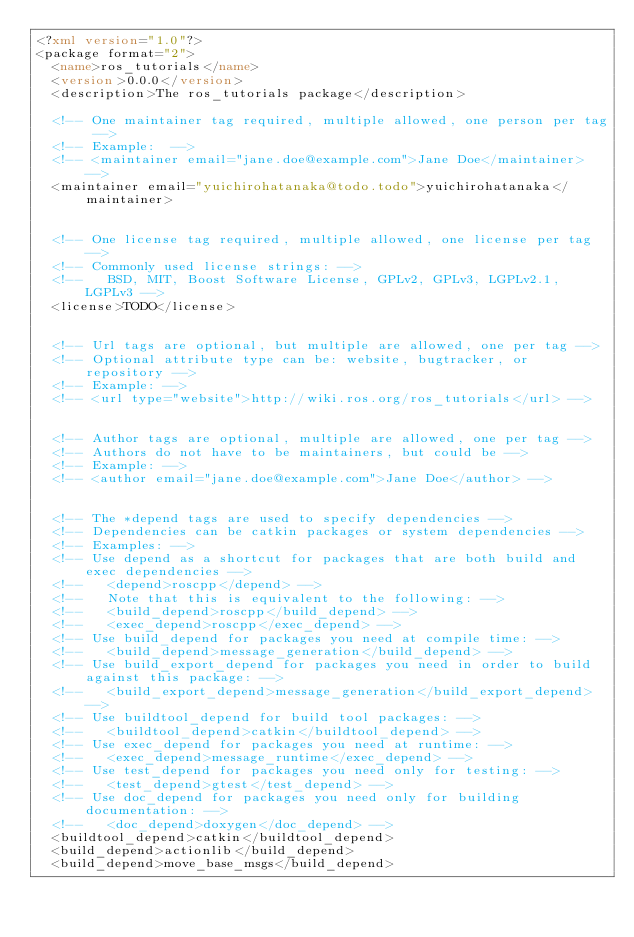Convert code to text. <code><loc_0><loc_0><loc_500><loc_500><_XML_><?xml version="1.0"?>
<package format="2">
  <name>ros_tutorials</name>
  <version>0.0.0</version>
  <description>The ros_tutorials package</description>

  <!-- One maintainer tag required, multiple allowed, one person per tag -->
  <!-- Example:  -->
  <!-- <maintainer email="jane.doe@example.com">Jane Doe</maintainer> -->
  <maintainer email="yuichirohatanaka@todo.todo">yuichirohatanaka</maintainer>


  <!-- One license tag required, multiple allowed, one license per tag -->
  <!-- Commonly used license strings: -->
  <!--   BSD, MIT, Boost Software License, GPLv2, GPLv3, LGPLv2.1, LGPLv3 -->
  <license>TODO</license>


  <!-- Url tags are optional, but multiple are allowed, one per tag -->
  <!-- Optional attribute type can be: website, bugtracker, or repository -->
  <!-- Example: -->
  <!-- <url type="website">http://wiki.ros.org/ros_tutorials</url> -->


  <!-- Author tags are optional, multiple are allowed, one per tag -->
  <!-- Authors do not have to be maintainers, but could be -->
  <!-- Example: -->
  <!-- <author email="jane.doe@example.com">Jane Doe</author> -->


  <!-- The *depend tags are used to specify dependencies -->
  <!-- Dependencies can be catkin packages or system dependencies -->
  <!-- Examples: -->
  <!-- Use depend as a shortcut for packages that are both build and exec dependencies -->
  <!--   <depend>roscpp</depend> -->
  <!--   Note that this is equivalent to the following: -->
  <!--   <build_depend>roscpp</build_depend> -->
  <!--   <exec_depend>roscpp</exec_depend> -->
  <!-- Use build_depend for packages you need at compile time: -->
  <!--   <build_depend>message_generation</build_depend> -->
  <!-- Use build_export_depend for packages you need in order to build against this package: -->
  <!--   <build_export_depend>message_generation</build_export_depend> -->
  <!-- Use buildtool_depend for build tool packages: -->
  <!--   <buildtool_depend>catkin</buildtool_depend> -->
  <!-- Use exec_depend for packages you need at runtime: -->
  <!--   <exec_depend>message_runtime</exec_depend> -->
  <!-- Use test_depend for packages you need only for testing: -->
  <!--   <test_depend>gtest</test_depend> -->
  <!-- Use doc_depend for packages you need only for building documentation: -->
  <!--   <doc_depend>doxygen</doc_depend> -->
  <buildtool_depend>catkin</buildtool_depend>
  <build_depend>actionlib</build_depend>
  <build_depend>move_base_msgs</build_depend></code> 